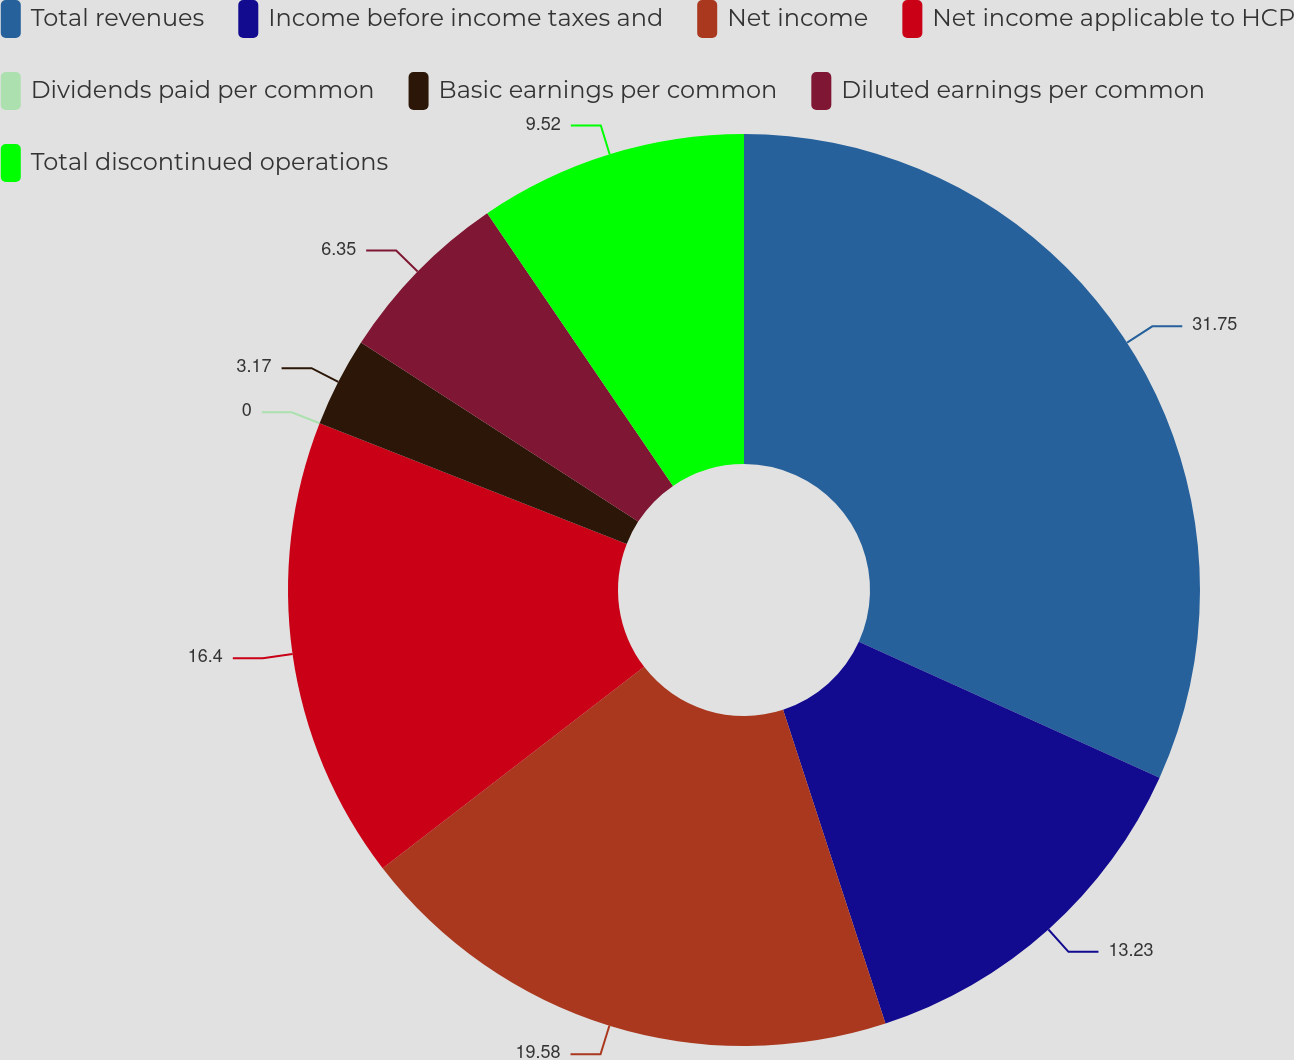Convert chart to OTSL. <chart><loc_0><loc_0><loc_500><loc_500><pie_chart><fcel>Total revenues<fcel>Income before income taxes and<fcel>Net income<fcel>Net income applicable to HCP<fcel>Dividends paid per common<fcel>Basic earnings per common<fcel>Diluted earnings per common<fcel>Total discontinued operations<nl><fcel>31.75%<fcel>13.23%<fcel>19.58%<fcel>16.4%<fcel>0.0%<fcel>3.17%<fcel>6.35%<fcel>9.52%<nl></chart> 